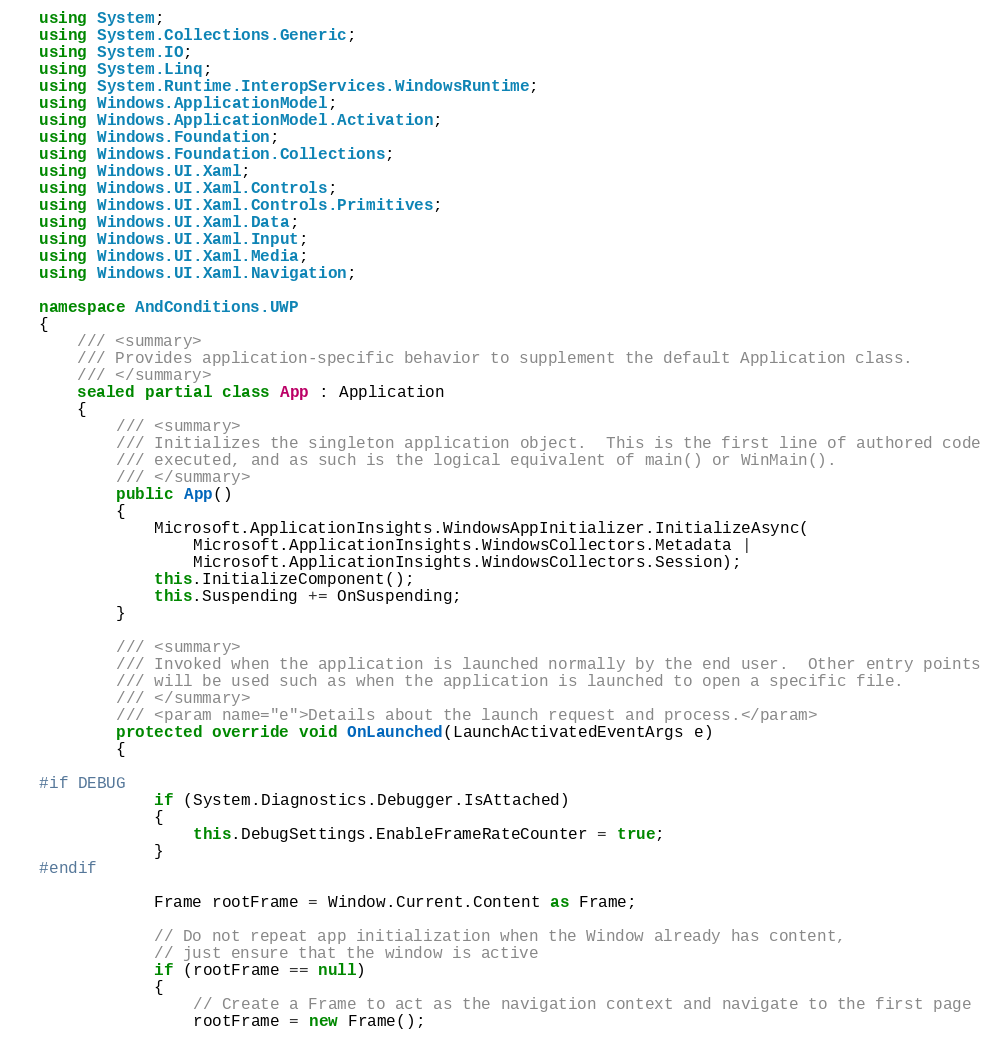<code> <loc_0><loc_0><loc_500><loc_500><_C#_>using System;
using System.Collections.Generic;
using System.IO;
using System.Linq;
using System.Runtime.InteropServices.WindowsRuntime;
using Windows.ApplicationModel;
using Windows.ApplicationModel.Activation;
using Windows.Foundation;
using Windows.Foundation.Collections;
using Windows.UI.Xaml;
using Windows.UI.Xaml.Controls;
using Windows.UI.Xaml.Controls.Primitives;
using Windows.UI.Xaml.Data;
using Windows.UI.Xaml.Input;
using Windows.UI.Xaml.Media;
using Windows.UI.Xaml.Navigation;

namespace AndConditions.UWP
{
    /// <summary>
    /// Provides application-specific behavior to supplement the default Application class.
    /// </summary>
    sealed partial class App : Application
    {
        /// <summary>
        /// Initializes the singleton application object.  This is the first line of authored code
        /// executed, and as such is the logical equivalent of main() or WinMain().
        /// </summary>
        public App()
        {
            Microsoft.ApplicationInsights.WindowsAppInitializer.InitializeAsync(
                Microsoft.ApplicationInsights.WindowsCollectors.Metadata |
                Microsoft.ApplicationInsights.WindowsCollectors.Session);
            this.InitializeComponent();
            this.Suspending += OnSuspending;
        }

        /// <summary>
        /// Invoked when the application is launched normally by the end user.  Other entry points
        /// will be used such as when the application is launched to open a specific file.
        /// </summary>
        /// <param name="e">Details about the launch request and process.</param>
        protected override void OnLaunched(LaunchActivatedEventArgs e)
        {

#if DEBUG
            if (System.Diagnostics.Debugger.IsAttached)
            {
                this.DebugSettings.EnableFrameRateCounter = true;
            }
#endif

            Frame rootFrame = Window.Current.Content as Frame;

            // Do not repeat app initialization when the Window already has content,
            // just ensure that the window is active
            if (rootFrame == null)
            {
                // Create a Frame to act as the navigation context and navigate to the first page
                rootFrame = new Frame();
</code> 